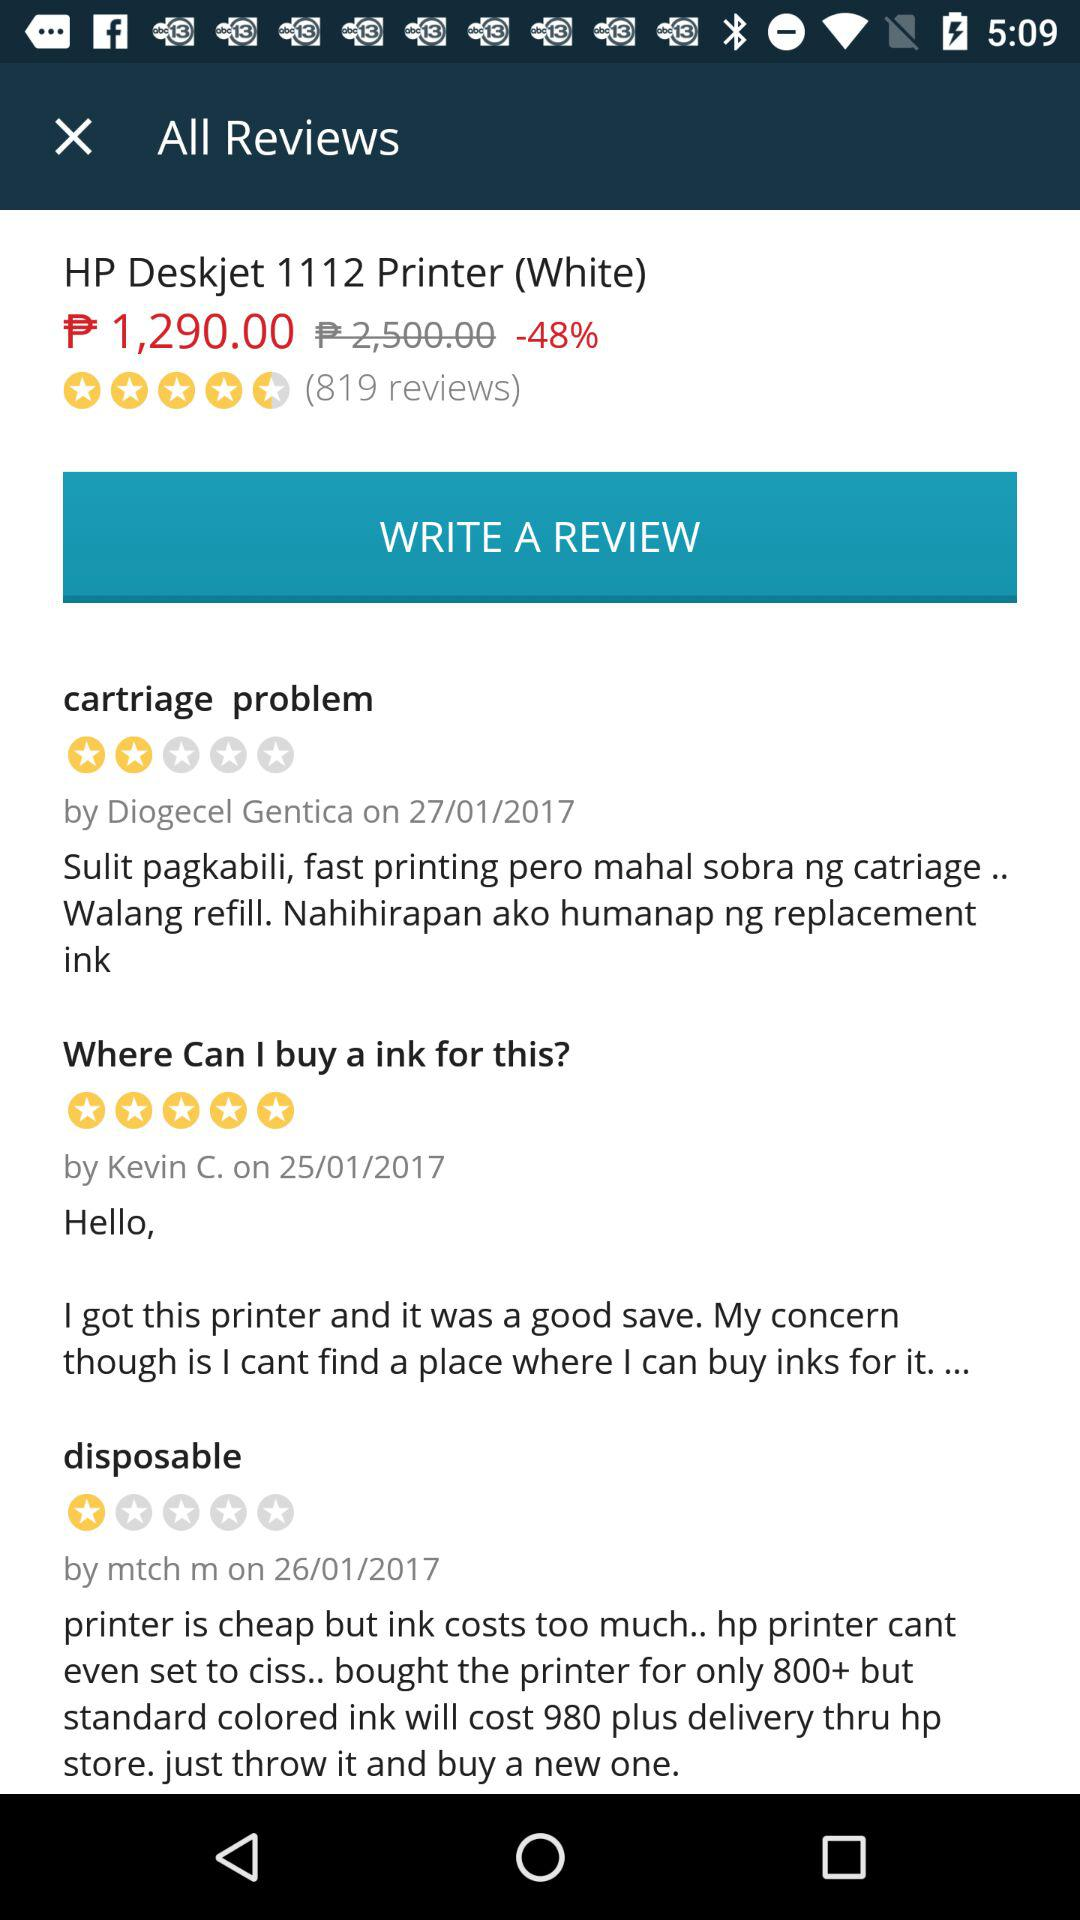When did "mtch m" give the review? The review was given on January 26, 2017. 